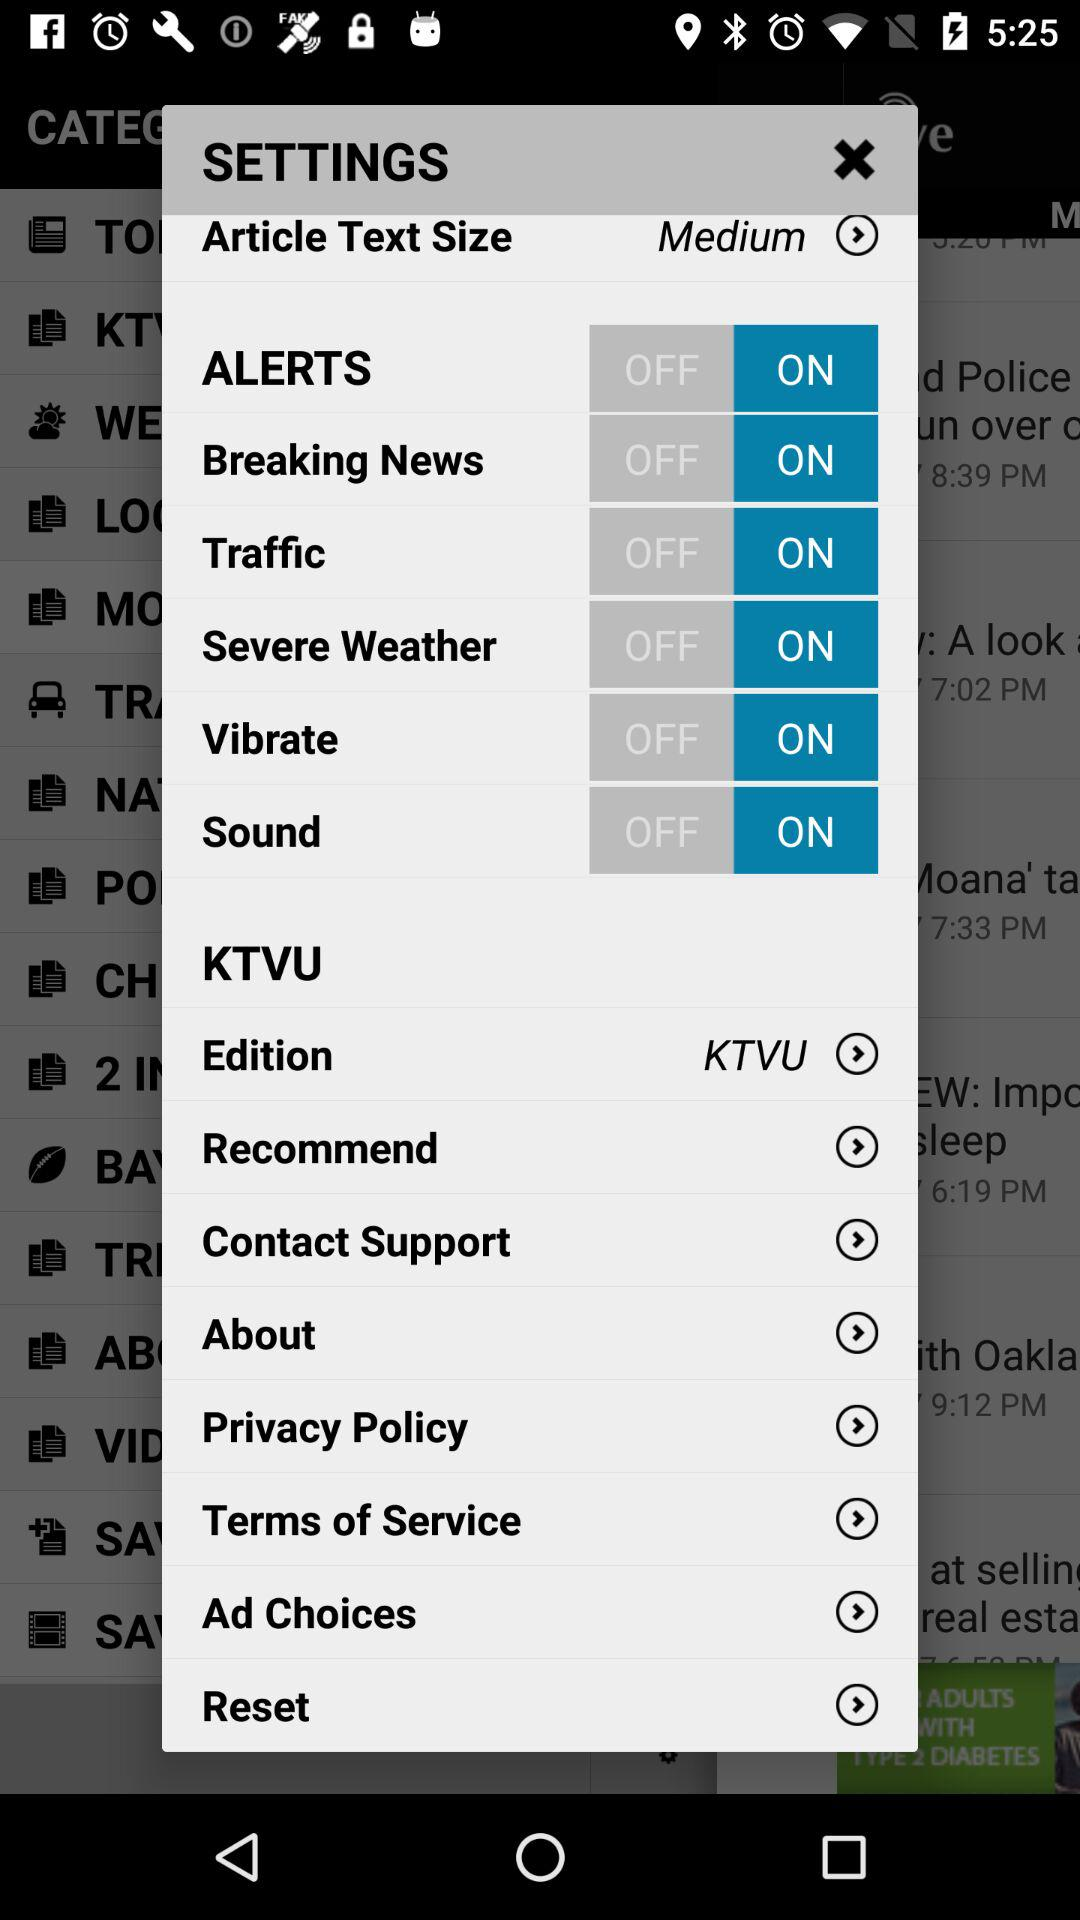What is the status of the "Sound"? The status of the "Sound" is "on". 